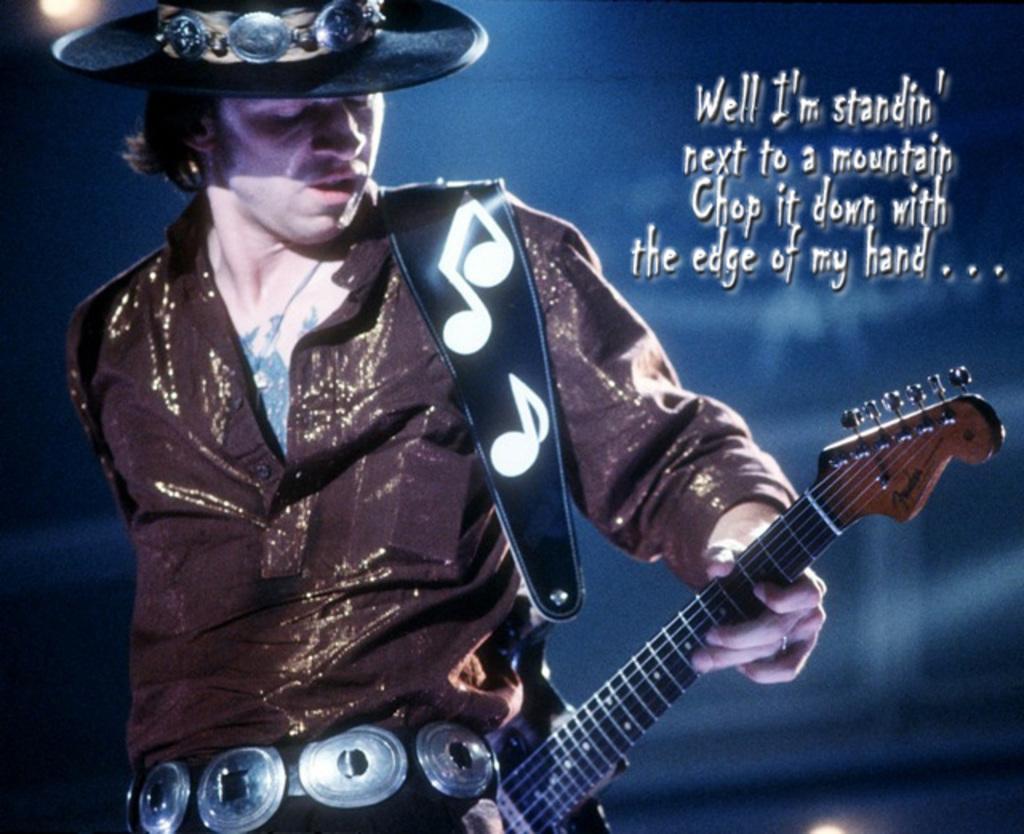Please provide a concise description of this image. In this image we have a man standing and playing a guitar. 